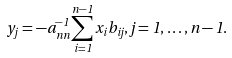Convert formula to latex. <formula><loc_0><loc_0><loc_500><loc_500>y _ { j } = - a _ { n n } ^ { - 1 } \sum _ { i = 1 } ^ { n - 1 } x _ { i } b _ { i j } , j = 1 , \dots , n - 1 .</formula> 